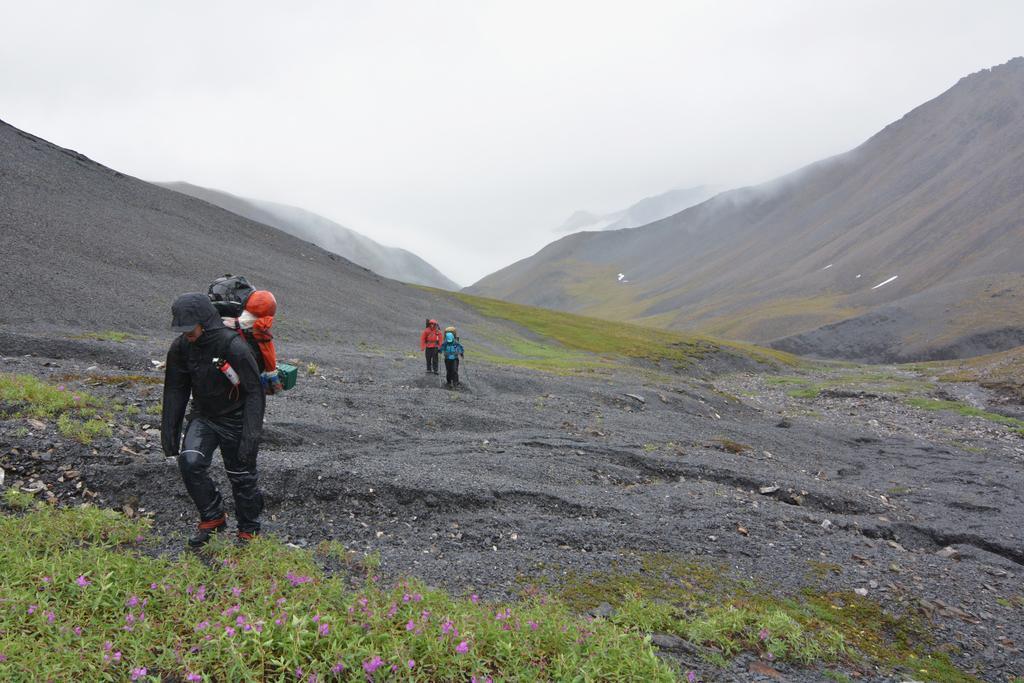Could you give a brief overview of what you see in this image? In this image there are three persons wearing bags and walking on a mountain, in the background there are mountains, in the bottom left there are plants. 